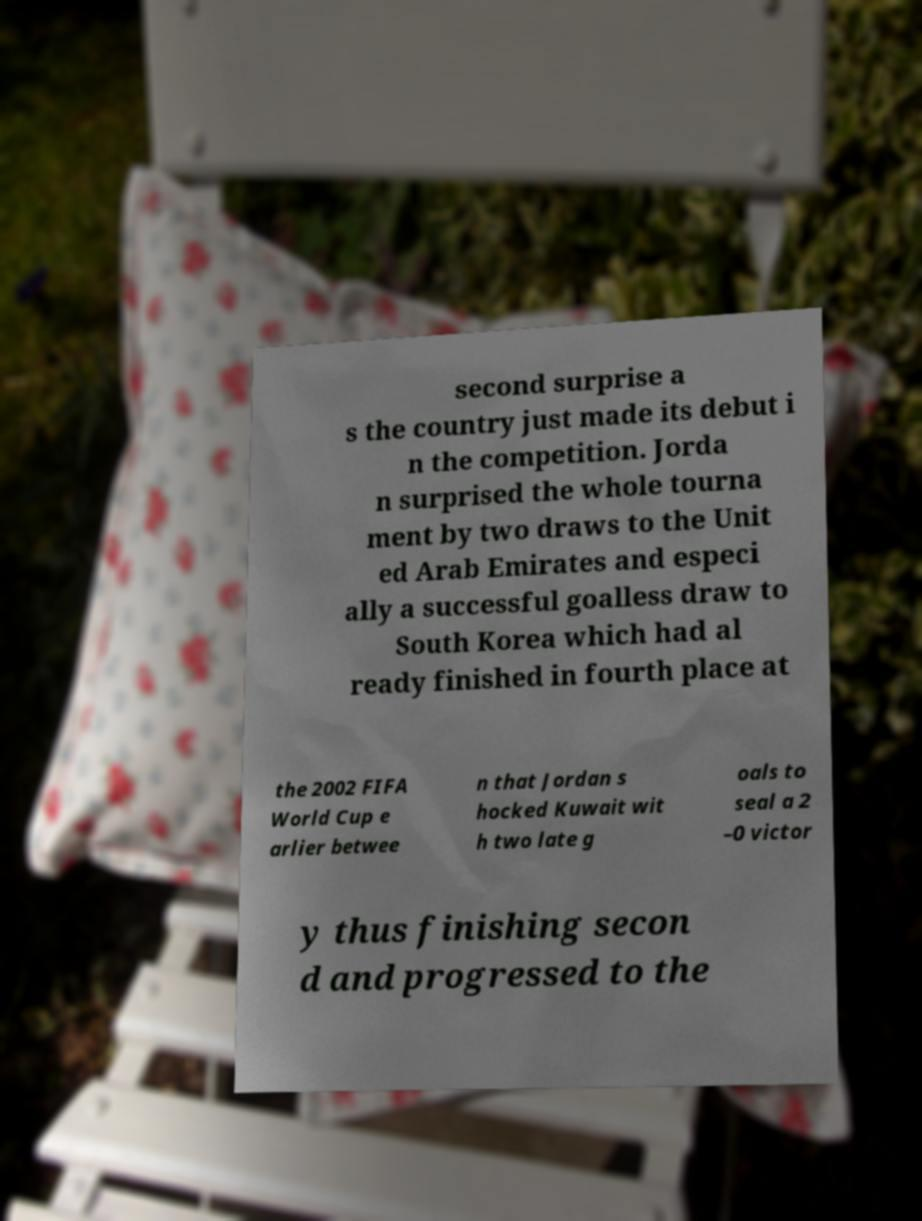Please identify and transcribe the text found in this image. second surprise a s the country just made its debut i n the competition. Jorda n surprised the whole tourna ment by two draws to the Unit ed Arab Emirates and especi ally a successful goalless draw to South Korea which had al ready finished in fourth place at the 2002 FIFA World Cup e arlier betwee n that Jordan s hocked Kuwait wit h two late g oals to seal a 2 –0 victor y thus finishing secon d and progressed to the 